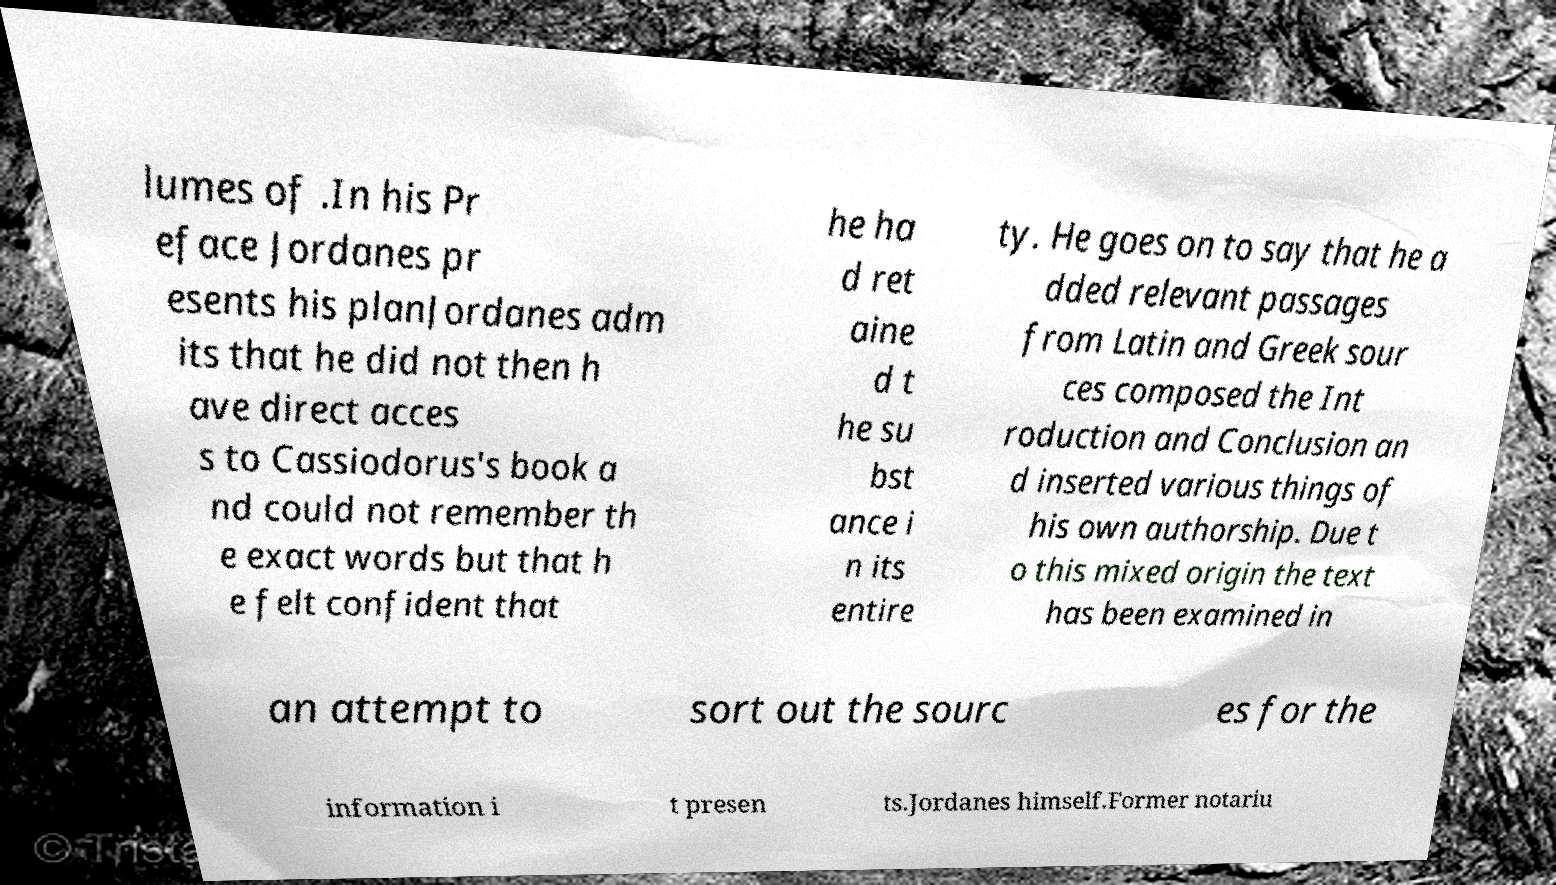Can you read and provide the text displayed in the image?This photo seems to have some interesting text. Can you extract and type it out for me? lumes of .In his Pr eface Jordanes pr esents his planJordanes adm its that he did not then h ave direct acces s to Cassiodorus's book a nd could not remember th e exact words but that h e felt confident that he ha d ret aine d t he su bst ance i n its entire ty. He goes on to say that he a dded relevant passages from Latin and Greek sour ces composed the Int roduction and Conclusion an d inserted various things of his own authorship. Due t o this mixed origin the text has been examined in an attempt to sort out the sourc es for the information i t presen ts.Jordanes himself.Former notariu 